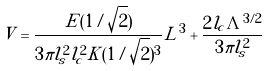<formula> <loc_0><loc_0><loc_500><loc_500>V = \frac { E ( 1 / \sqrt { 2 } ) } { 3 \pi l _ { s } ^ { 2 } l _ { c } ^ { 2 } K ( 1 / \sqrt { 2 } ) ^ { 3 } } L ^ { 3 } + \frac { 2 l _ { c } \Lambda ^ { 3 / 2 } } { 3 \pi l _ { s } ^ { 2 } }</formula> 